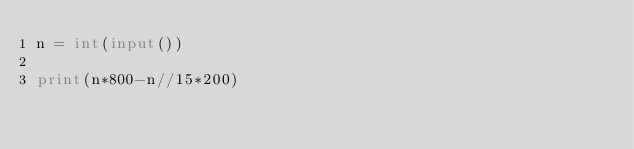<code> <loc_0><loc_0><loc_500><loc_500><_Python_>n = int(input())

print(n*800-n//15*200)
</code> 